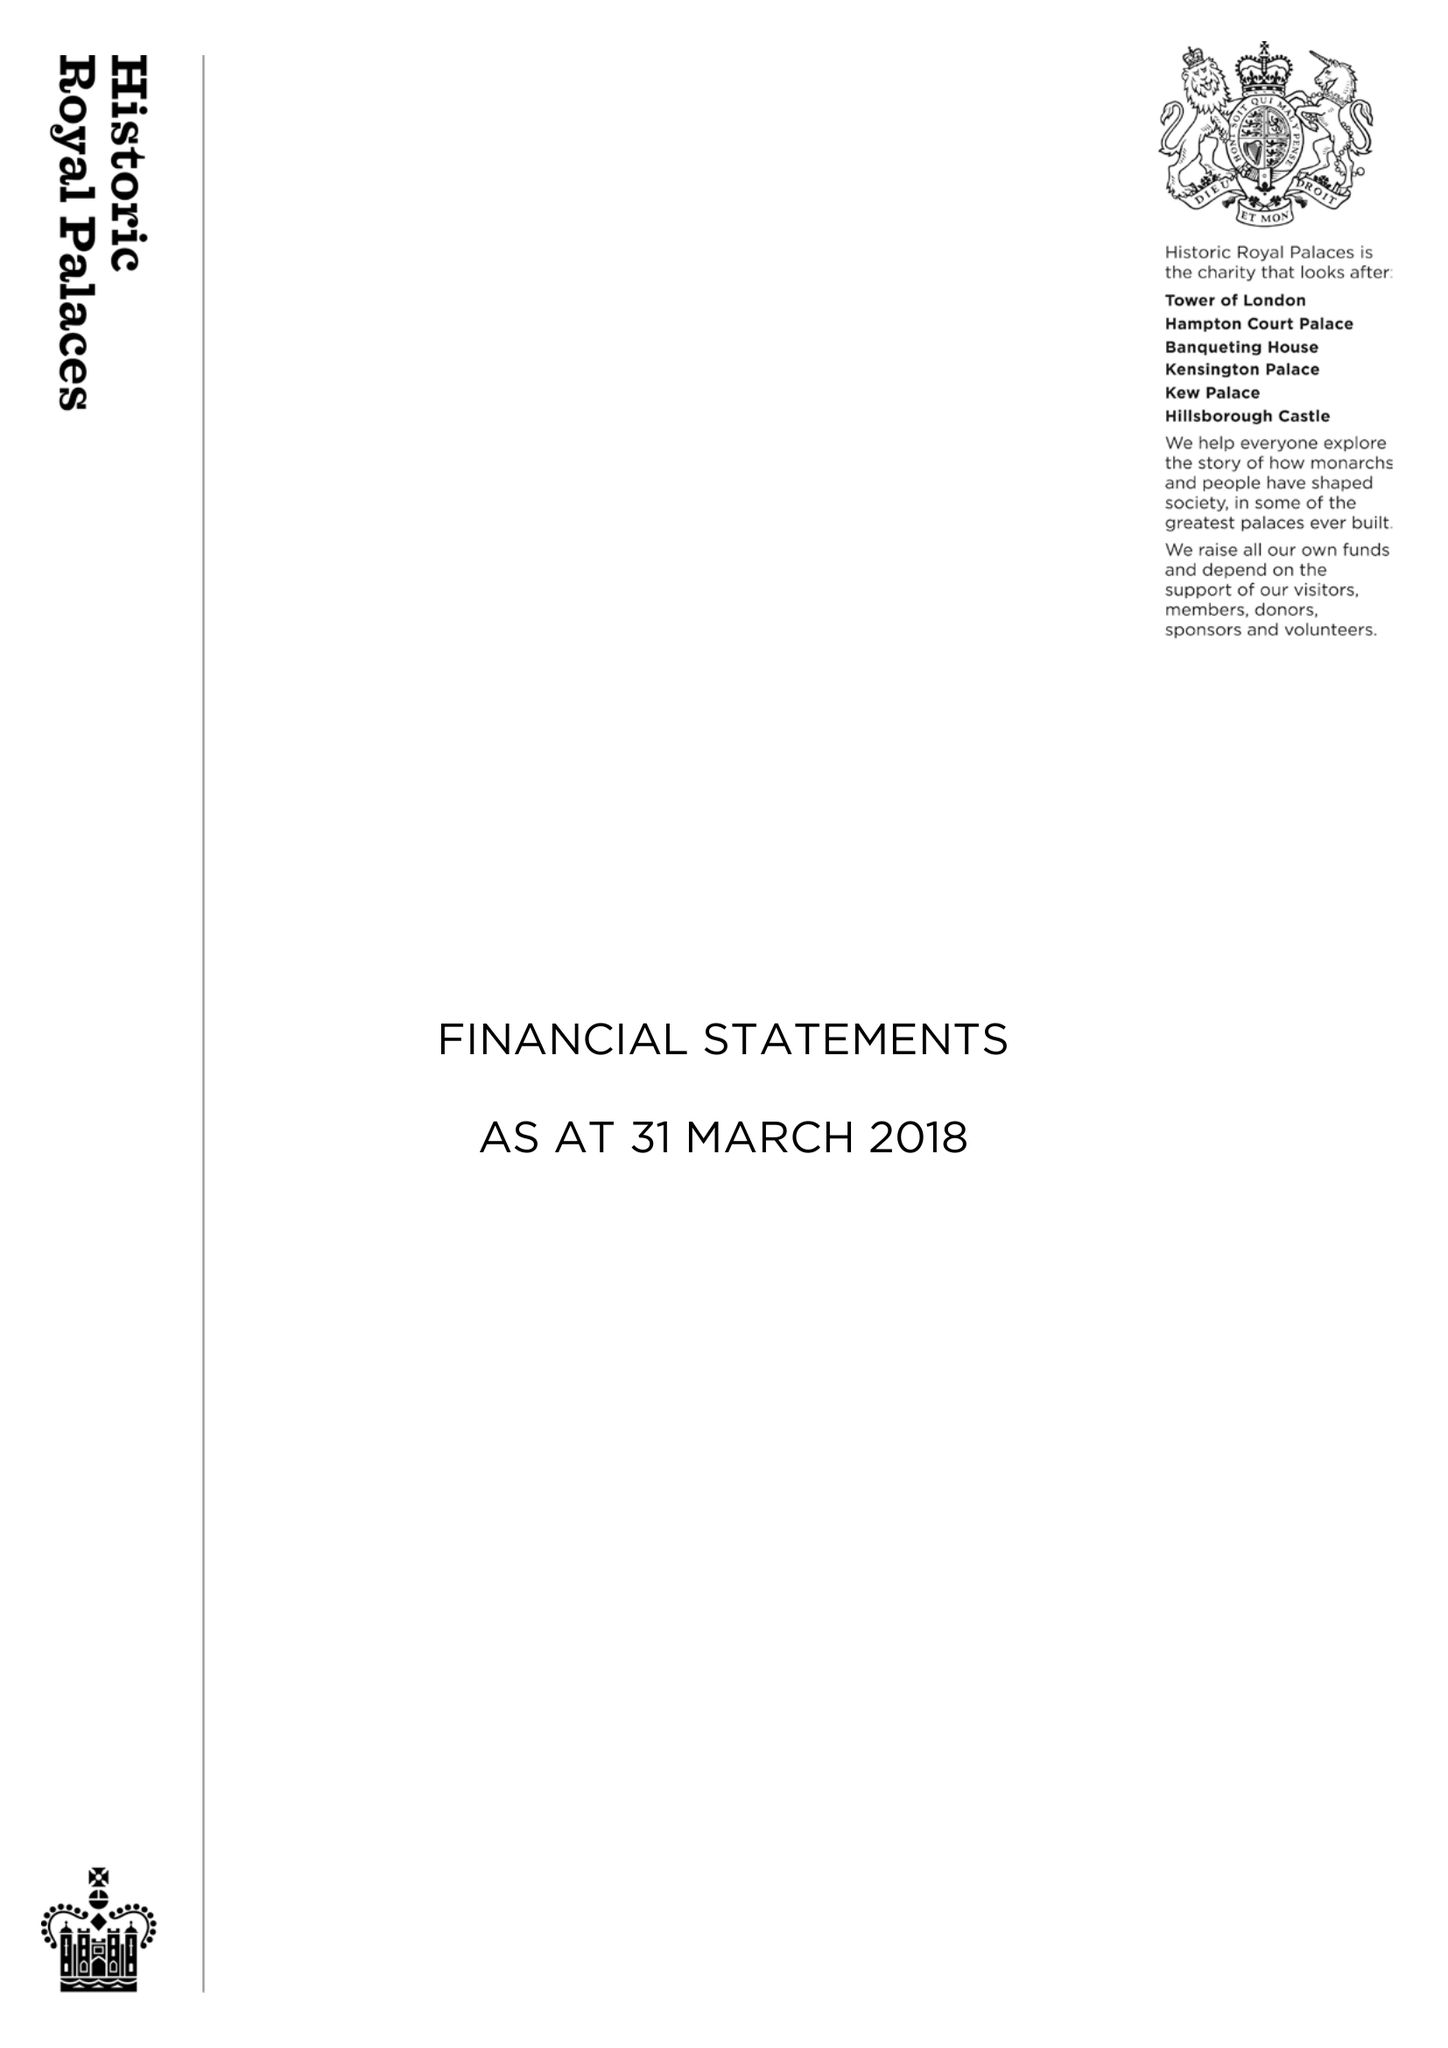What is the value for the charity_name?
Answer the question using a single word or phrase. Historic Royal Palaces 